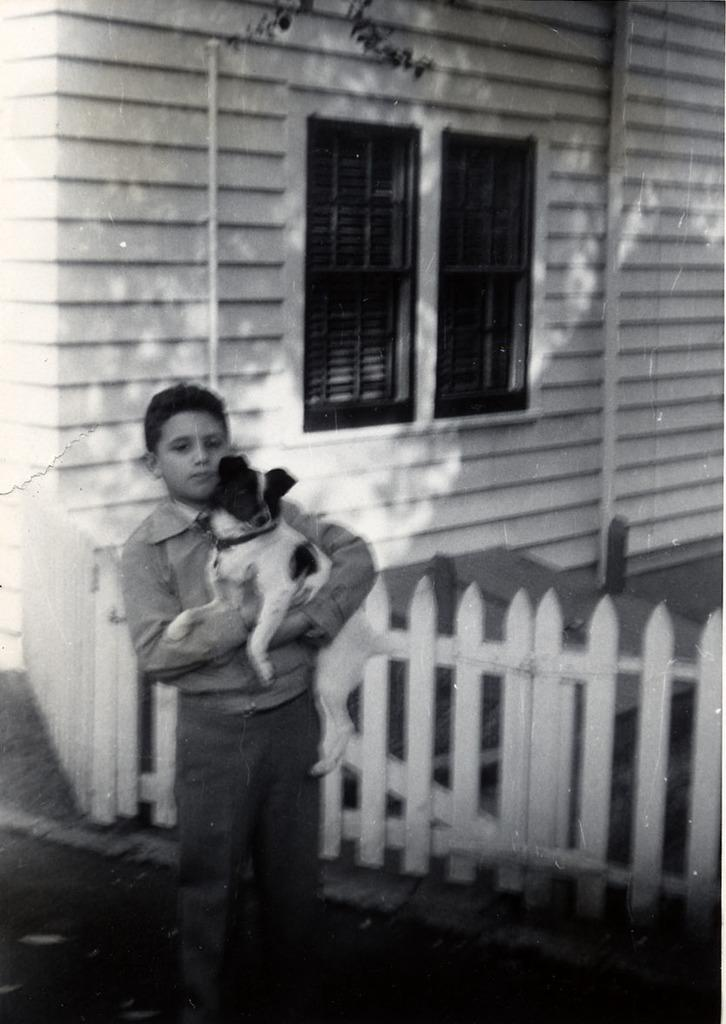Who is present in the image? There is a boy in the image. What is the boy doing in the image? The boy is standing and holding a dog. What can be seen in the background of the image? There is a building with windows in the background of the image. What type of fencing is visible in the image? There is a wooden fencing in the image. What type of tax is being discussed in the image? There is no mention of tax or any discussion in the image; it features a boy holding a dog with wooden fencing and a building in the background. 